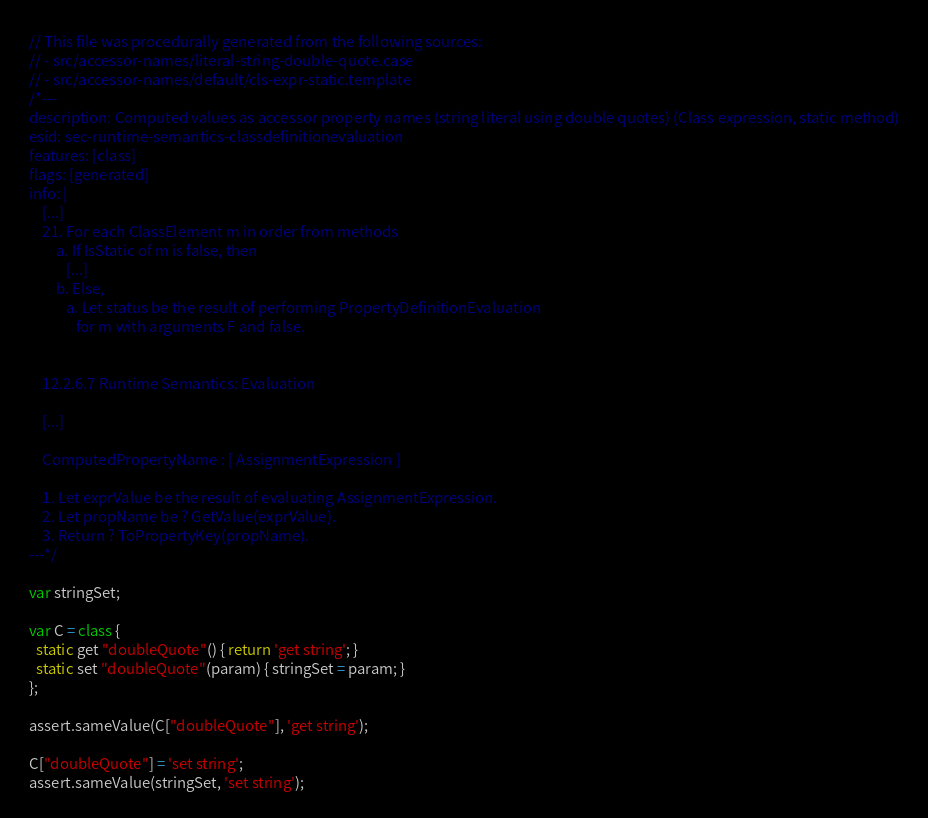<code> <loc_0><loc_0><loc_500><loc_500><_JavaScript_>// This file was procedurally generated from the following sources:
// - src/accessor-names/literal-string-double-quote.case
// - src/accessor-names/default/cls-expr-static.template
/*---
description: Computed values as accessor property names (string literal using double quotes) (Class expression, static method)
esid: sec-runtime-semantics-classdefinitionevaluation
features: [class]
flags: [generated]
info: |
    [...]
    21. For each ClassElement m in order from methods
        a. If IsStatic of m is false, then
           [...]
        b. Else,
           a. Let status be the result of performing PropertyDefinitionEvaluation
              for m with arguments F and false.


    12.2.6.7 Runtime Semantics: Evaluation

    [...]

    ComputedPropertyName : [ AssignmentExpression ]

    1. Let exprValue be the result of evaluating AssignmentExpression.
    2. Let propName be ? GetValue(exprValue).
    3. Return ? ToPropertyKey(propName).
---*/

var stringSet;

var C = class {
  static get "doubleQuote"() { return 'get string'; }
  static set "doubleQuote"(param) { stringSet = param; }
};

assert.sameValue(C["doubleQuote"], 'get string');

C["doubleQuote"] = 'set string';
assert.sameValue(stringSet, 'set string');
</code> 